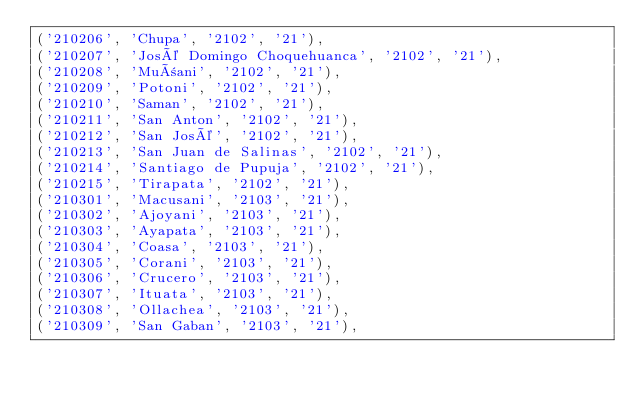Convert code to text. <code><loc_0><loc_0><loc_500><loc_500><_SQL_>('210206', 'Chupa', '2102', '21'),
('210207', 'José Domingo Choquehuanca', '2102', '21'),
('210208', 'Muñani', '2102', '21'),
('210209', 'Potoni', '2102', '21'),
('210210', 'Saman', '2102', '21'),
('210211', 'San Anton', '2102', '21'),
('210212', 'San José', '2102', '21'),
('210213', 'San Juan de Salinas', '2102', '21'),
('210214', 'Santiago de Pupuja', '2102', '21'),
('210215', 'Tirapata', '2102', '21'),
('210301', 'Macusani', '2103', '21'),
('210302', 'Ajoyani', '2103', '21'),
('210303', 'Ayapata', '2103', '21'),
('210304', 'Coasa', '2103', '21'),
('210305', 'Corani', '2103', '21'),
('210306', 'Crucero', '2103', '21'),
('210307', 'Ituata', '2103', '21'),
('210308', 'Ollachea', '2103', '21'),
('210309', 'San Gaban', '2103', '21'),</code> 